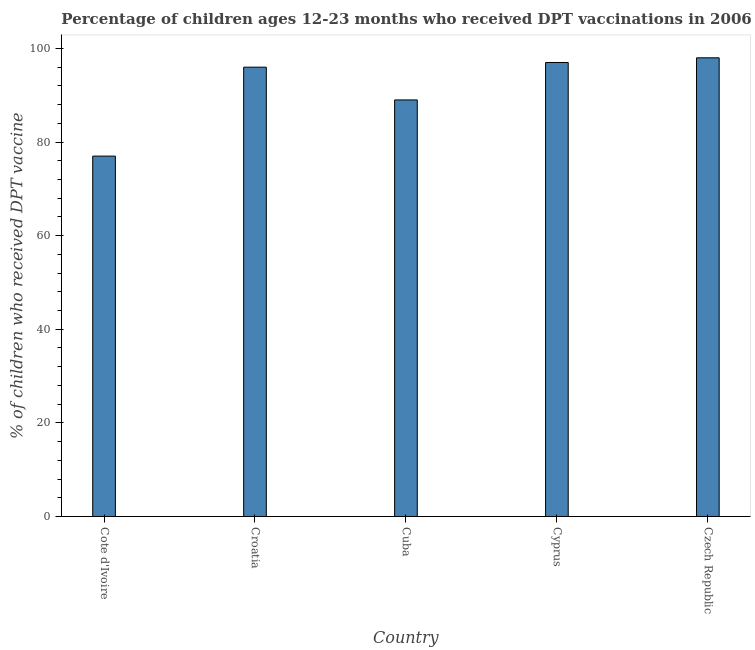Does the graph contain any zero values?
Offer a very short reply. No. What is the title of the graph?
Your answer should be very brief. Percentage of children ages 12-23 months who received DPT vaccinations in 2006. What is the label or title of the X-axis?
Your response must be concise. Country. What is the label or title of the Y-axis?
Make the answer very short. % of children who received DPT vaccine. What is the percentage of children who received dpt vaccine in Croatia?
Your answer should be very brief. 96. Across all countries, what is the maximum percentage of children who received dpt vaccine?
Offer a very short reply. 98. Across all countries, what is the minimum percentage of children who received dpt vaccine?
Offer a terse response. 77. In which country was the percentage of children who received dpt vaccine maximum?
Your answer should be compact. Czech Republic. In which country was the percentage of children who received dpt vaccine minimum?
Your answer should be compact. Cote d'Ivoire. What is the sum of the percentage of children who received dpt vaccine?
Make the answer very short. 457. What is the average percentage of children who received dpt vaccine per country?
Offer a terse response. 91.4. What is the median percentage of children who received dpt vaccine?
Give a very brief answer. 96. What is the ratio of the percentage of children who received dpt vaccine in Cote d'Ivoire to that in Cyprus?
Make the answer very short. 0.79. Is the percentage of children who received dpt vaccine in Cote d'Ivoire less than that in Croatia?
Make the answer very short. Yes. Is the difference between the percentage of children who received dpt vaccine in Cote d'Ivoire and Cyprus greater than the difference between any two countries?
Keep it short and to the point. No. What is the difference between the highest and the second highest percentage of children who received dpt vaccine?
Give a very brief answer. 1. In how many countries, is the percentage of children who received dpt vaccine greater than the average percentage of children who received dpt vaccine taken over all countries?
Your response must be concise. 3. What is the difference between two consecutive major ticks on the Y-axis?
Your response must be concise. 20. Are the values on the major ticks of Y-axis written in scientific E-notation?
Your answer should be compact. No. What is the % of children who received DPT vaccine in Croatia?
Make the answer very short. 96. What is the % of children who received DPT vaccine in Cuba?
Make the answer very short. 89. What is the % of children who received DPT vaccine of Cyprus?
Provide a succinct answer. 97. What is the % of children who received DPT vaccine in Czech Republic?
Give a very brief answer. 98. What is the difference between the % of children who received DPT vaccine in Cote d'Ivoire and Cuba?
Provide a succinct answer. -12. What is the difference between the % of children who received DPT vaccine in Cote d'Ivoire and Cyprus?
Your response must be concise. -20. What is the difference between the % of children who received DPT vaccine in Cote d'Ivoire and Czech Republic?
Provide a succinct answer. -21. What is the difference between the % of children who received DPT vaccine in Croatia and Cuba?
Offer a terse response. 7. What is the difference between the % of children who received DPT vaccine in Croatia and Cyprus?
Make the answer very short. -1. What is the difference between the % of children who received DPT vaccine in Cuba and Czech Republic?
Ensure brevity in your answer.  -9. What is the ratio of the % of children who received DPT vaccine in Cote d'Ivoire to that in Croatia?
Your response must be concise. 0.8. What is the ratio of the % of children who received DPT vaccine in Cote d'Ivoire to that in Cuba?
Offer a terse response. 0.86. What is the ratio of the % of children who received DPT vaccine in Cote d'Ivoire to that in Cyprus?
Provide a succinct answer. 0.79. What is the ratio of the % of children who received DPT vaccine in Cote d'Ivoire to that in Czech Republic?
Your answer should be compact. 0.79. What is the ratio of the % of children who received DPT vaccine in Croatia to that in Cuba?
Give a very brief answer. 1.08. What is the ratio of the % of children who received DPT vaccine in Croatia to that in Cyprus?
Your answer should be very brief. 0.99. What is the ratio of the % of children who received DPT vaccine in Cuba to that in Cyprus?
Ensure brevity in your answer.  0.92. What is the ratio of the % of children who received DPT vaccine in Cuba to that in Czech Republic?
Make the answer very short. 0.91. What is the ratio of the % of children who received DPT vaccine in Cyprus to that in Czech Republic?
Provide a succinct answer. 0.99. 